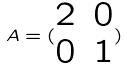Convert formula to latex. <formula><loc_0><loc_0><loc_500><loc_500>A = ( \begin{matrix} 2 & 0 \\ 0 & 1 \end{matrix} )</formula> 